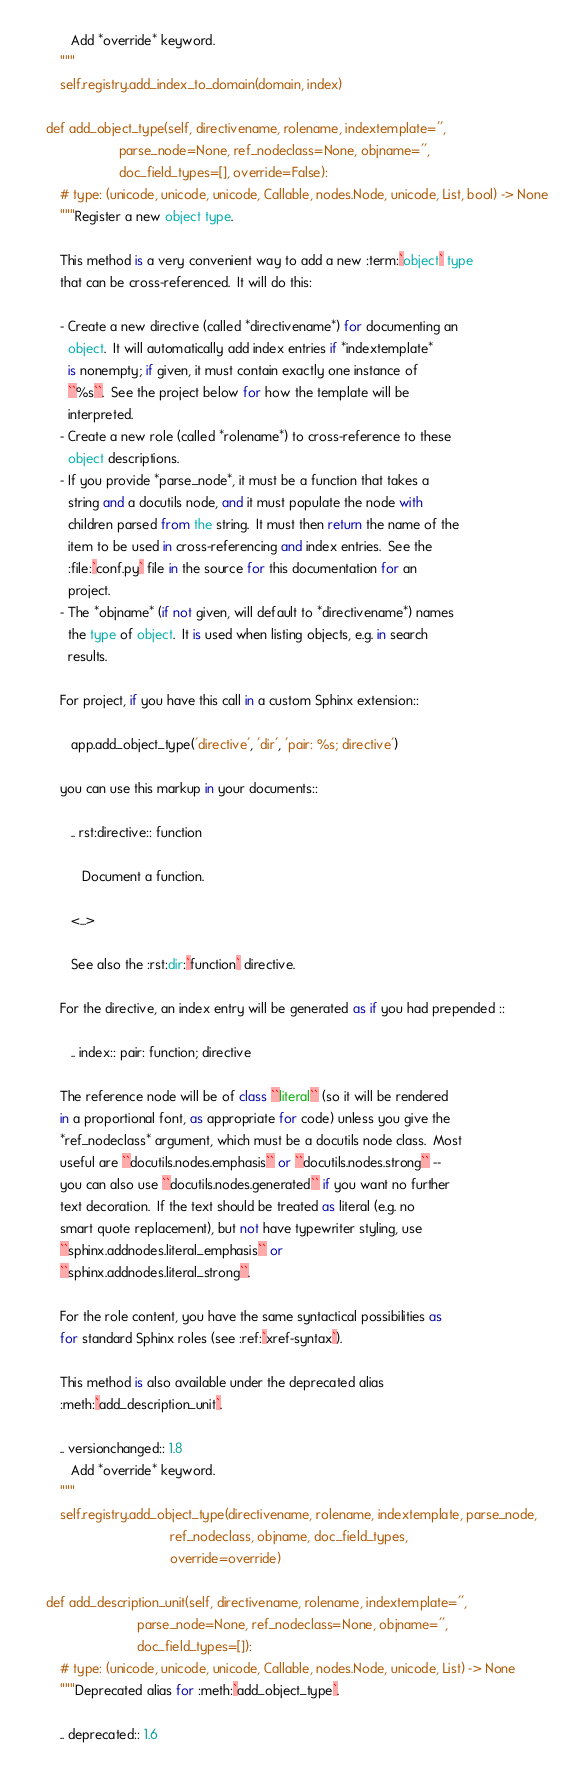<code> <loc_0><loc_0><loc_500><loc_500><_Python_>           Add *override* keyword.
        """
        self.registry.add_index_to_domain(domain, index)

    def add_object_type(self, directivename, rolename, indextemplate='',
                        parse_node=None, ref_nodeclass=None, objname='',
                        doc_field_types=[], override=False):
        # type: (unicode, unicode, unicode, Callable, nodes.Node, unicode, List, bool) -> None
        """Register a new object type.

        This method is a very convenient way to add a new :term:`object` type
        that can be cross-referenced.  It will do this:

        - Create a new directive (called *directivename*) for documenting an
          object.  It will automatically add index entries if *indextemplate*
          is nonempty; if given, it must contain exactly one instance of
          ``%s``.  See the project below for how the template will be
          interpreted.
        - Create a new role (called *rolename*) to cross-reference to these
          object descriptions.
        - If you provide *parse_node*, it must be a function that takes a
          string and a docutils node, and it must populate the node with
          children parsed from the string.  It must then return the name of the
          item to be used in cross-referencing and index entries.  See the
          :file:`conf.py` file in the source for this documentation for an
          project.
        - The *objname* (if not given, will default to *directivename*) names
          the type of object.  It is used when listing objects, e.g. in search
          results.

        For project, if you have this call in a custom Sphinx extension::

           app.add_object_type('directive', 'dir', 'pair: %s; directive')

        you can use this markup in your documents::

           .. rst:directive:: function

              Document a function.

           <...>

           See also the :rst:dir:`function` directive.

        For the directive, an index entry will be generated as if you had prepended ::

           .. index:: pair: function; directive

        The reference node will be of class ``literal`` (so it will be rendered
        in a proportional font, as appropriate for code) unless you give the
        *ref_nodeclass* argument, which must be a docutils node class.  Most
        useful are ``docutils.nodes.emphasis`` or ``docutils.nodes.strong`` --
        you can also use ``docutils.nodes.generated`` if you want no further
        text decoration.  If the text should be treated as literal (e.g. no
        smart quote replacement), but not have typewriter styling, use
        ``sphinx.addnodes.literal_emphasis`` or
        ``sphinx.addnodes.literal_strong``.

        For the role content, you have the same syntactical possibilities as
        for standard Sphinx roles (see :ref:`xref-syntax`).

        This method is also available under the deprecated alias
        :meth:`add_description_unit`.

        .. versionchanged:: 1.8
           Add *override* keyword.
        """
        self.registry.add_object_type(directivename, rolename, indextemplate, parse_node,
                                      ref_nodeclass, objname, doc_field_types,
                                      override=override)

    def add_description_unit(self, directivename, rolename, indextemplate='',
                             parse_node=None, ref_nodeclass=None, objname='',
                             doc_field_types=[]):
        # type: (unicode, unicode, unicode, Callable, nodes.Node, unicode, List) -> None
        """Deprecated alias for :meth:`add_object_type`.

        .. deprecated:: 1.6</code> 